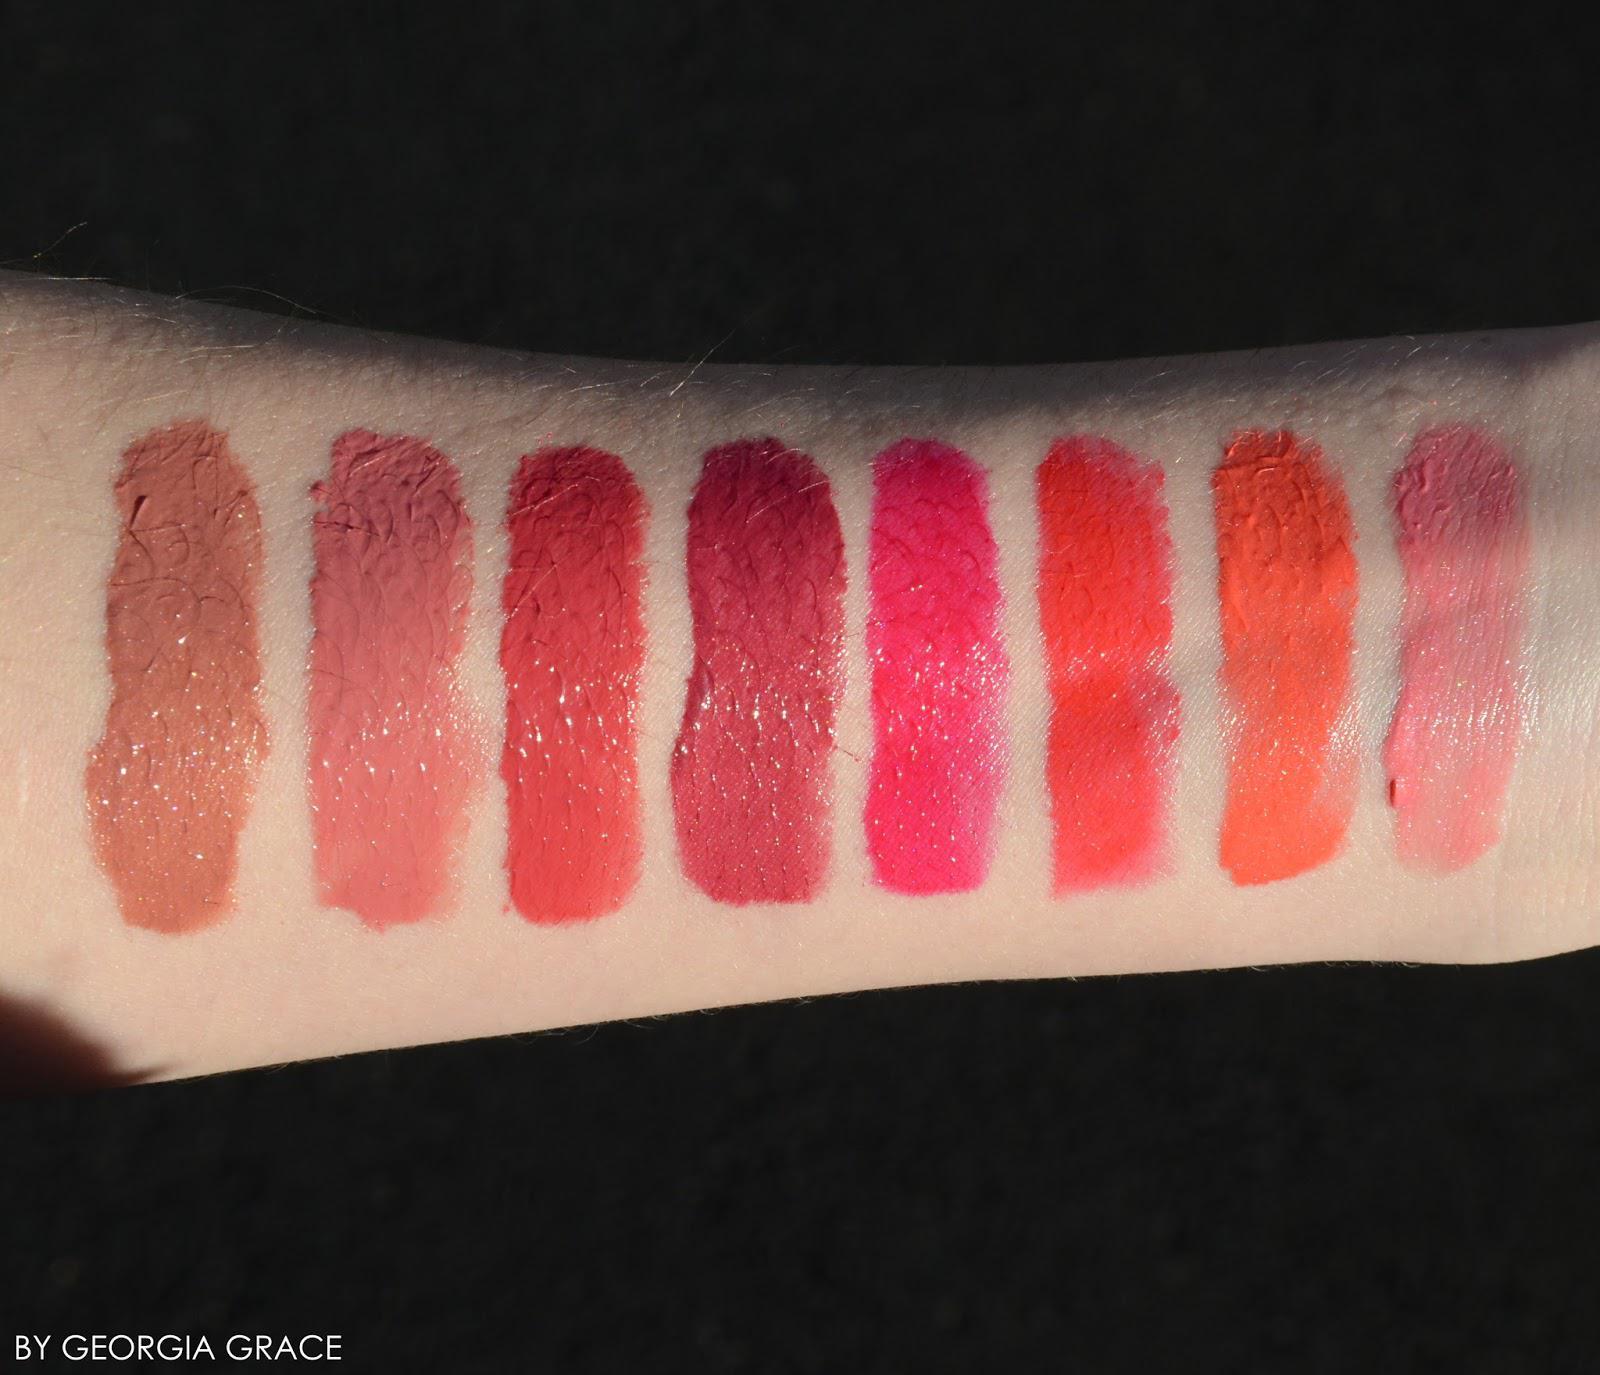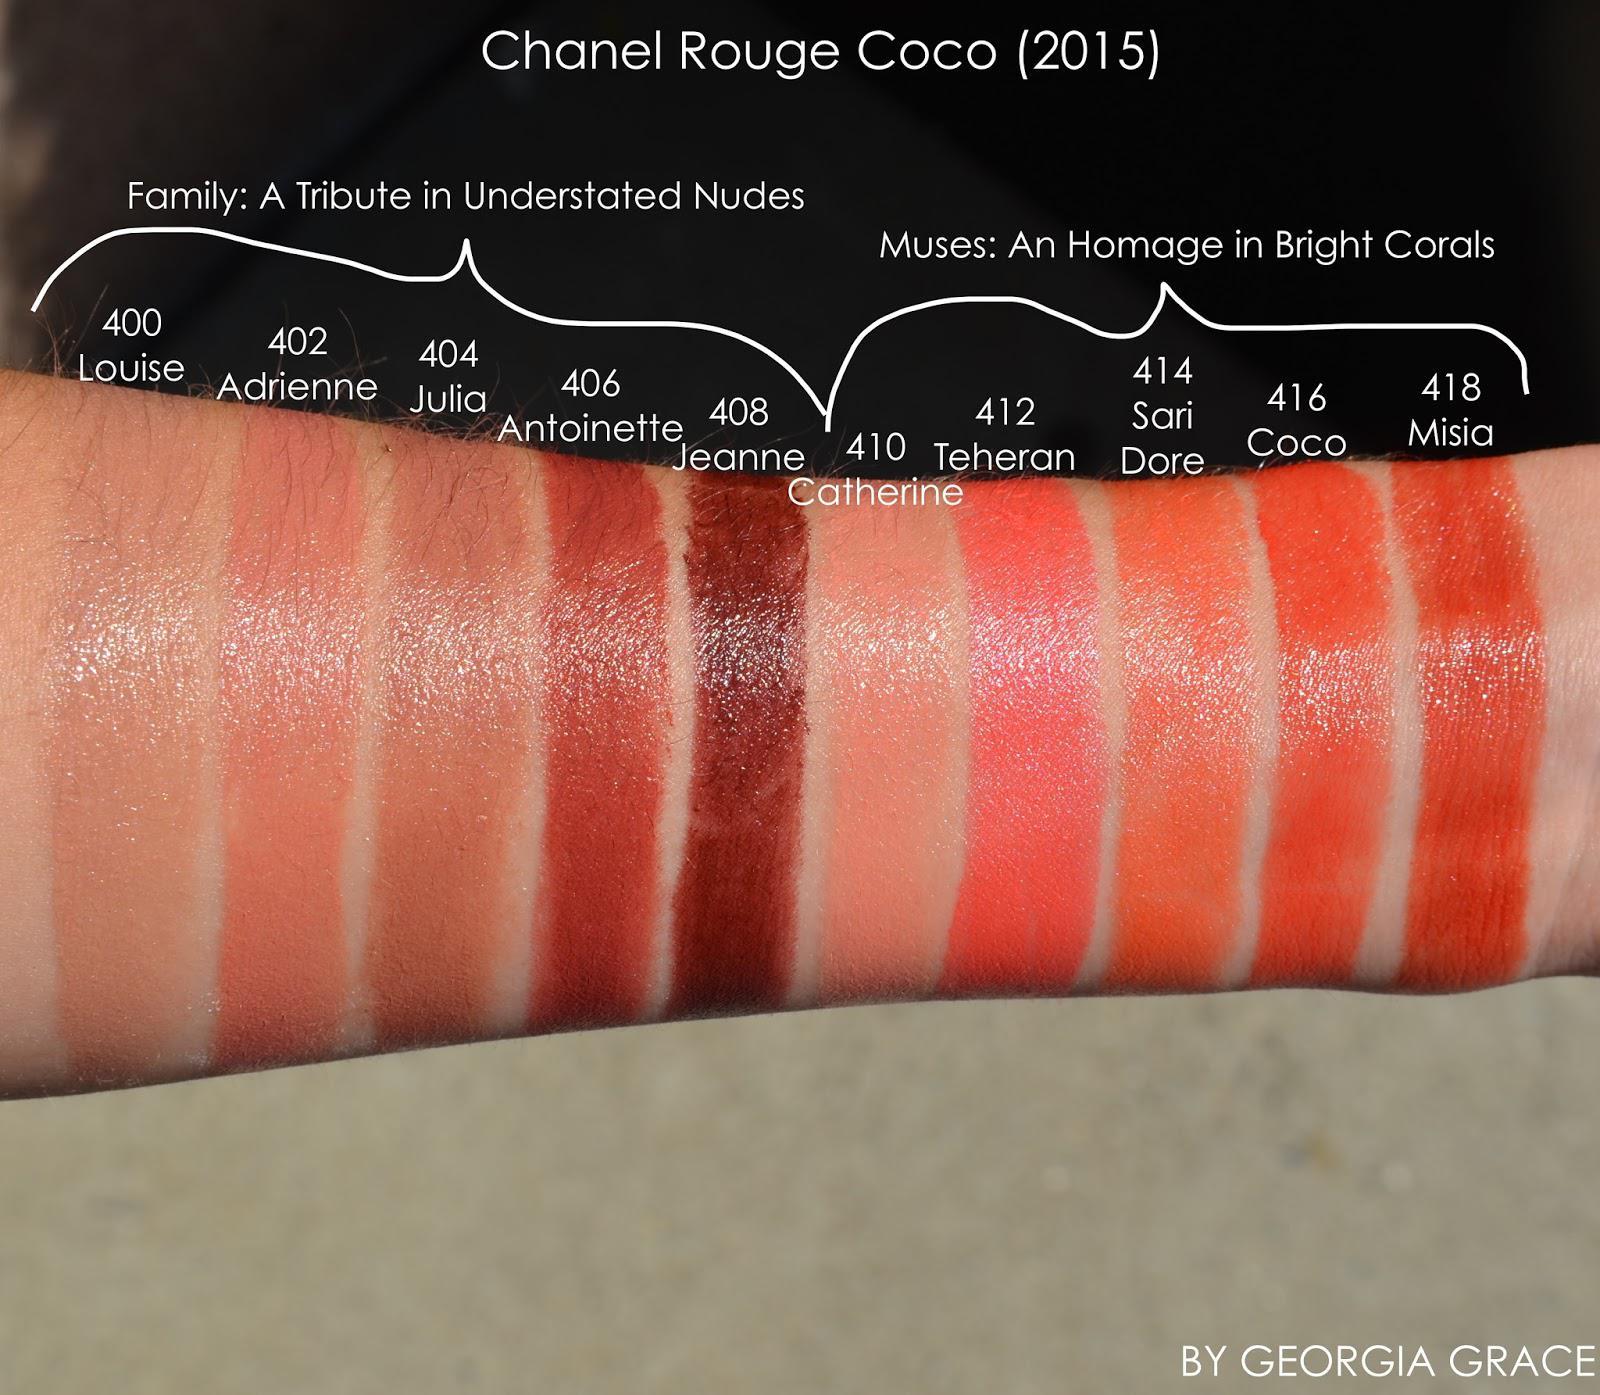The first image is the image on the left, the second image is the image on the right. For the images shown, is this caption "Differebt shades of lip stick are shoen on aerial view and above lipstick shades shown on human skin." true? Answer yes or no. No. The first image is the image on the left, the second image is the image on the right. Evaluate the accuracy of this statement regarding the images: "An image shows a row of lipstick pots above a row of lipstick streaks on human skin.". Is it true? Answer yes or no. No. 